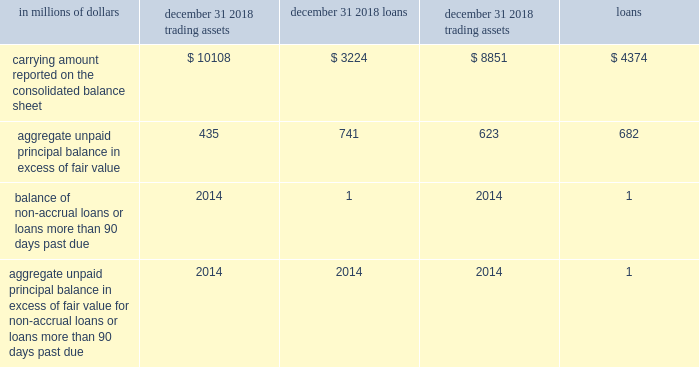Own debt valuation adjustments ( dva ) own debt valuation adjustments are recognized on citi 2019s liabilities for which the fair value option has been elected using citi 2019s credit spreads observed in the bond market .
Effective january 1 , 2016 , changes in fair value of fair value option liabilities related to changes in citigroup 2019s own credit spreads ( dva ) are reflected as a component of aoci .
See note 1 to the consolidated financial statements for additional information .
Among other variables , the fair value of liabilities for which the fair value option has been elected ( other than non-recourse and similar liabilities ) is impacted by the narrowing or widening of the company 2019s credit spreads .
The estimated changes in the fair value of these liabilities due to such changes in the company 2019s own credit spread ( or instrument-specific credit risk ) were a gain of $ 1415 million and a loss of $ 680 million for the years ended december 31 , 2018 and 2017 , respectively .
Changes in fair value resulting from changes in instrument-specific credit risk were estimated by incorporating the company 2019s current credit spreads observable in the bond market into the relevant valuation technique used to value each liability as described above .
The fair value option for financial assets and financial liabilities selected portfolios of securities purchased under agreements to resell , securities borrowed , securities sold under agreements to repurchase , securities loaned and certain non-collateralized short-term borrowings the company elected the fair value option for certain portfolios of fixed income securities purchased under agreements to resell and fixed income securities sold under agreements to repurchase , securities borrowed , securities loaned and certain non-collateralized short-term borrowings held primarily by broker-dealer entities in the united states , united kingdom and japan .
In each case , the election was made because the related interest rate risk is managed on a portfolio basis , primarily with offsetting derivative instruments that are accounted for at fair value through earnings .
Changes in fair value for transactions in these portfolios are recorded in principal transactions .
The related interest revenue and interest expense are measured based on the contractual rates specified in the transactions and are reported as interest revenue and interest expense in the consolidated statement of income .
Certain loans and other credit products citigroup has also elected the fair value option for certain other originated and purchased loans , including certain unfunded loan products , such as guarantees and letters of credit , executed by citigroup 2019s lending and trading businesses .
None of these credit products are highly leveraged financing commitments .
Significant groups of transactions include loans and unfunded loan products that are expected to be either sold or securitized in the near term , or transactions where the economic risks are hedged with derivative instruments , such as purchased credit default swaps or total return swaps where the company pays the total return on the underlying loans to a third party .
Citigroup has elected the fair value option to mitigate accounting mismatches in cases where hedge accounting is complex and to achieve operational simplifications .
Fair value was not elected for most lending transactions across the company .
The table provides information about certain credit products carried at fair value: .
In addition to the amounts reported above , $ 1137 million and $ 508 million of unfunded commitments related to certain credit products selected for fair value accounting were outstanding as of december 31 , 2018 and 2017 , respectively. .
What was the difference in millions of carrying amount reported on the consolidated balance sheet for loans between 2018 and the year prior? 
Computations: (3224 - 4374)
Answer: -1150.0. 